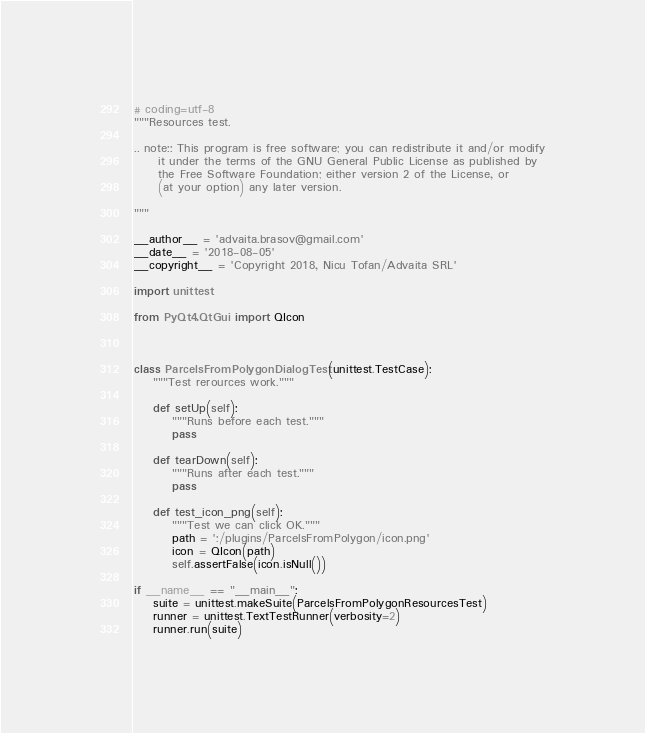<code> <loc_0><loc_0><loc_500><loc_500><_Python_># coding=utf-8
"""Resources test.

.. note:: This program is free software; you can redistribute it and/or modify
     it under the terms of the GNU General Public License as published by
     the Free Software Foundation; either version 2 of the License, or
     (at your option) any later version.

"""

__author__ = 'advaita.brasov@gmail.com'
__date__ = '2018-08-05'
__copyright__ = 'Copyright 2018, Nicu Tofan/Advaita SRL'

import unittest

from PyQt4.QtGui import QIcon



class ParcelsFromPolygonDialogTest(unittest.TestCase):
    """Test rerources work."""

    def setUp(self):
        """Runs before each test."""
        pass

    def tearDown(self):
        """Runs after each test."""
        pass

    def test_icon_png(self):
        """Test we can click OK."""
        path = ':/plugins/ParcelsFromPolygon/icon.png'
        icon = QIcon(path)
        self.assertFalse(icon.isNull())

if __name__ == "__main__":
    suite = unittest.makeSuite(ParcelsFromPolygonResourcesTest)
    runner = unittest.TextTestRunner(verbosity=2)
    runner.run(suite)



</code> 